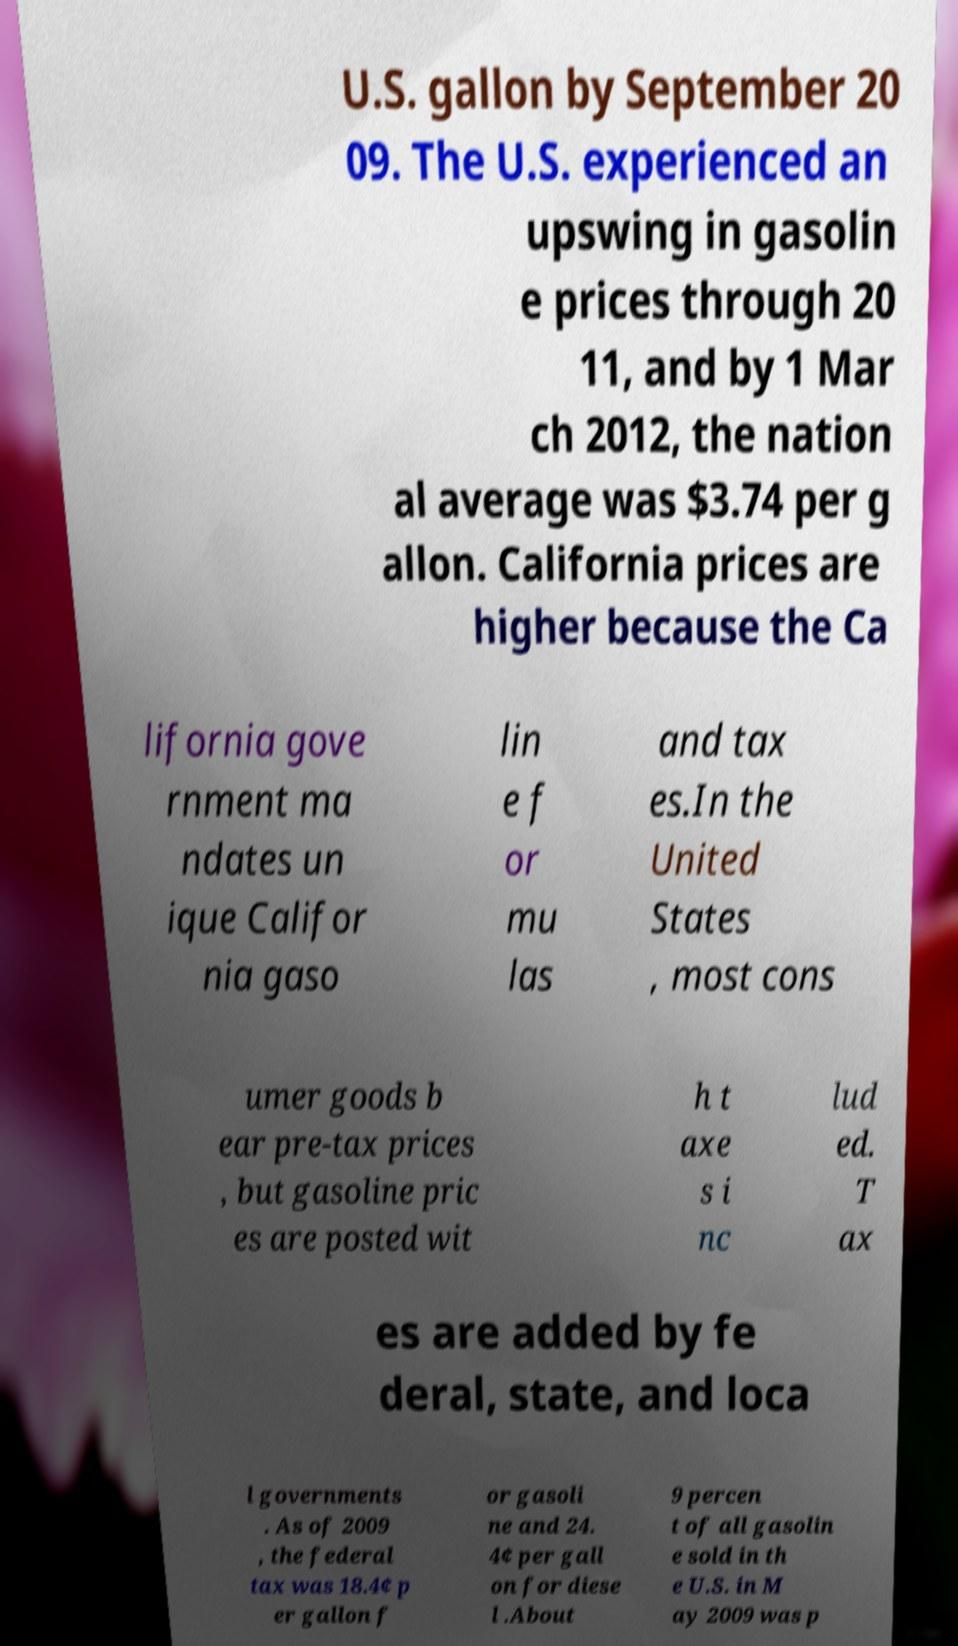What messages or text are displayed in this image? I need them in a readable, typed format. U.S. gallon by September 20 09. The U.S. experienced an upswing in gasolin e prices through 20 11, and by 1 Mar ch 2012, the nation al average was $3.74 per g allon. California prices are higher because the Ca lifornia gove rnment ma ndates un ique Califor nia gaso lin e f or mu las and tax es.In the United States , most cons umer goods b ear pre-tax prices , but gasoline pric es are posted wit h t axe s i nc lud ed. T ax es are added by fe deral, state, and loca l governments . As of 2009 , the federal tax was 18.4¢ p er gallon f or gasoli ne and 24. 4¢ per gall on for diese l .About 9 percen t of all gasolin e sold in th e U.S. in M ay 2009 was p 